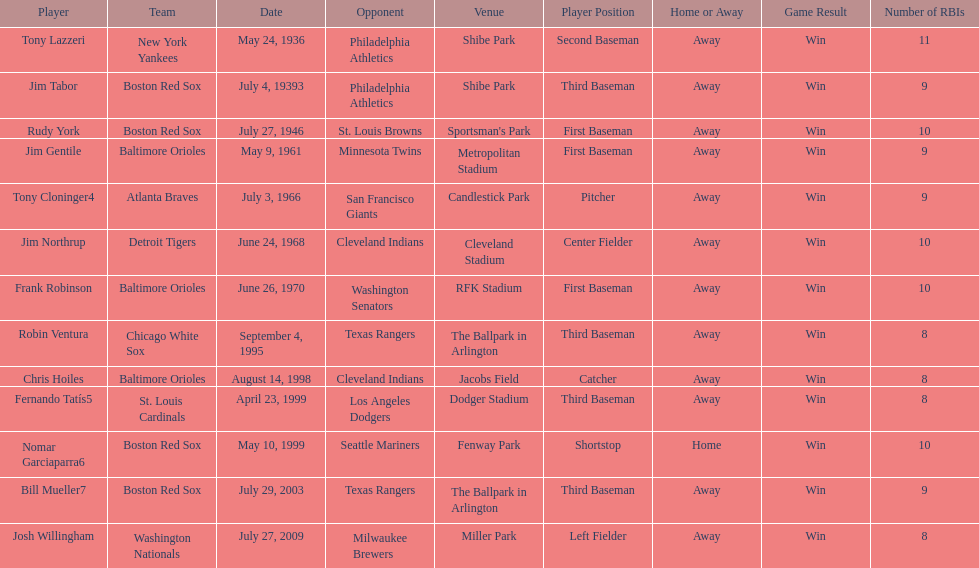Who is the first major league hitter to hit two grand slams in one game? Tony Lazzeri. 